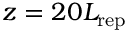Convert formula to latex. <formula><loc_0><loc_0><loc_500><loc_500>z = 2 0 L _ { r e p }</formula> 